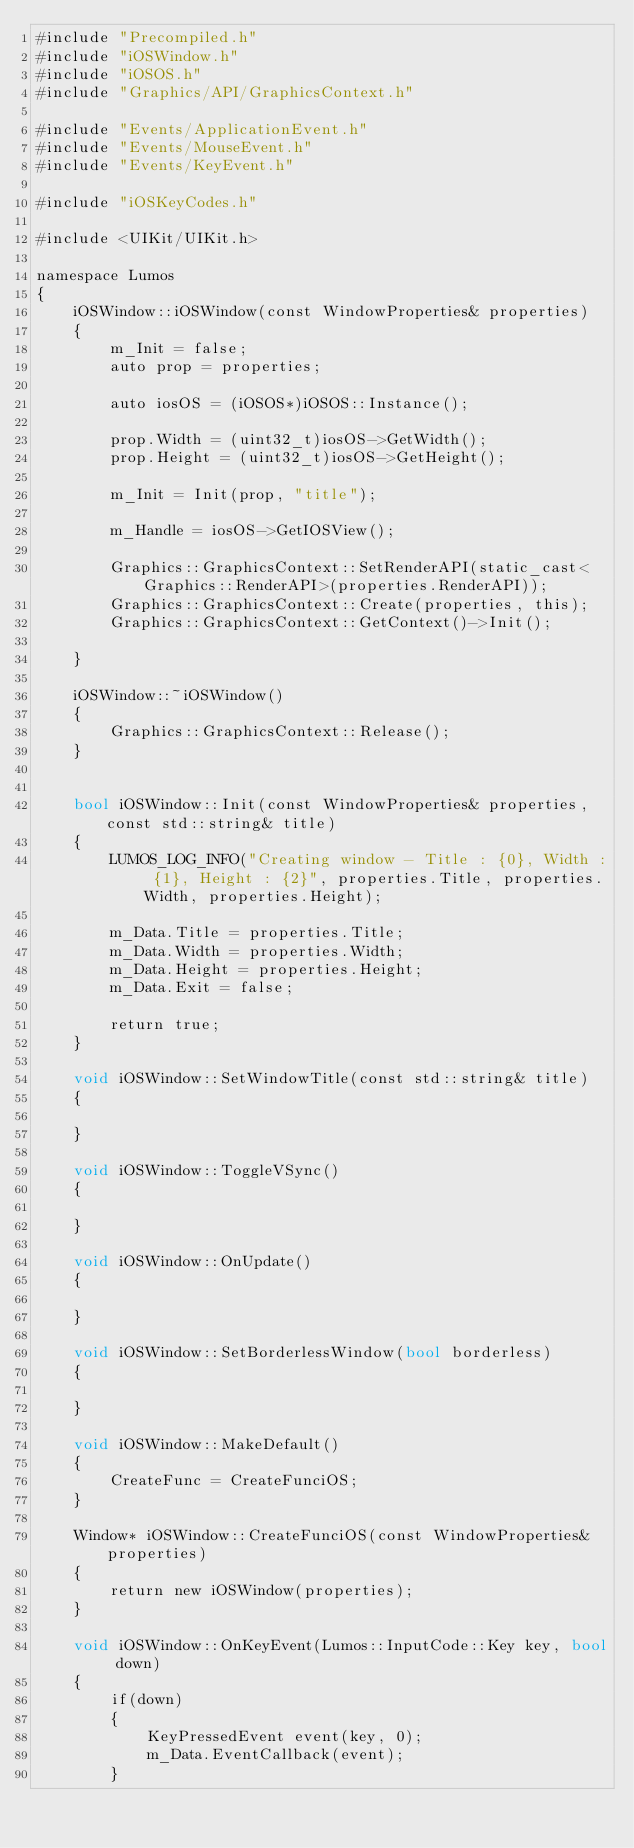Convert code to text. <code><loc_0><loc_0><loc_500><loc_500><_ObjectiveC_>#include "Precompiled.h"
#include "iOSWindow.h"
#include "iOSOS.h"
#include "Graphics/API/GraphicsContext.h"

#include "Events/ApplicationEvent.h"
#include "Events/MouseEvent.h"
#include "Events/KeyEvent.h"

#include "iOSKeyCodes.h"

#include <UIKit/UIKit.h>

namespace Lumos
{
	iOSWindow::iOSWindow(const WindowProperties& properties)
	{
		m_Init = false;
        auto prop = properties;
        
        auto iosOS = (iOSOS*)iOSOS::Instance();

        prop.Width = (uint32_t)iosOS->GetWidth();
        prop.Height = (uint32_t)iosOS->GetHeight();

		m_Init = Init(prop, "title");
        
        m_Handle = iosOS->GetIOSView();
        
		Graphics::GraphicsContext::SetRenderAPI(static_cast<Graphics::RenderAPI>(properties.RenderAPI));
		Graphics::GraphicsContext::Create(properties, this);
		Graphics::GraphicsContext::GetContext()->Init();
		
	}

	iOSWindow::~iOSWindow()
	{
		Graphics::GraphicsContext::Release();
	}


	bool iOSWindow::Init(const WindowProperties& properties, const std::string& title)
	{
        LUMOS_LOG_INFO("Creating window - Title : {0}, Width : {1}, Height : {2}", properties.Title, properties.Width, properties.Height);

        m_Data.Title = properties.Title;
        m_Data.Width = properties.Width;
        m_Data.Height = properties.Height;
        m_Data.Exit = false;
        
		return true;
	}

	void iOSWindow::SetWindowTitle(const std::string& title)
	{

	}

	void iOSWindow::ToggleVSync()
	{

	}
    
	void iOSWindow::OnUpdate()
	{

	}

	void iOSWindow::SetBorderlessWindow(bool borderless)
	{

	}

	void iOSWindow::MakeDefault()
	{
		CreateFunc = CreateFunciOS;
	}

	Window* iOSWindow::CreateFunciOS(const WindowProperties& properties)
	{
		return new iOSWindow(properties);
	}

    void iOSWindow::OnKeyEvent(Lumos::InputCode::Key key, bool down)
    {
        if(down)
        {
            KeyPressedEvent event(key, 0);
            m_Data.EventCallback(event);
        }</code> 